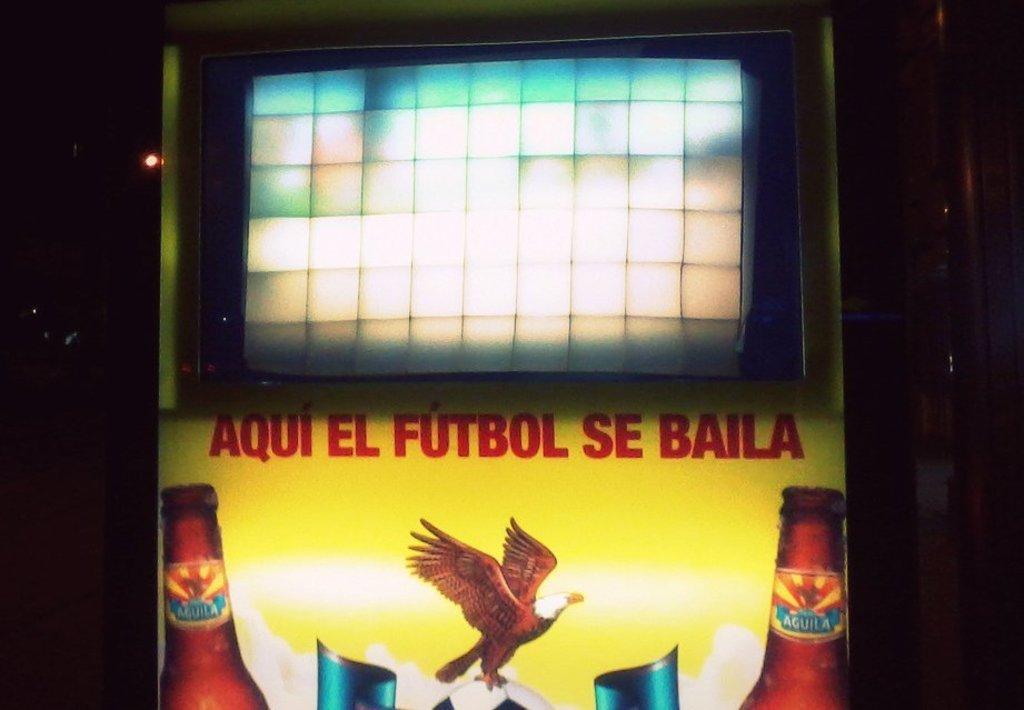What sport does this yellow sign refer to?
Provide a succinct answer. Futbol. 